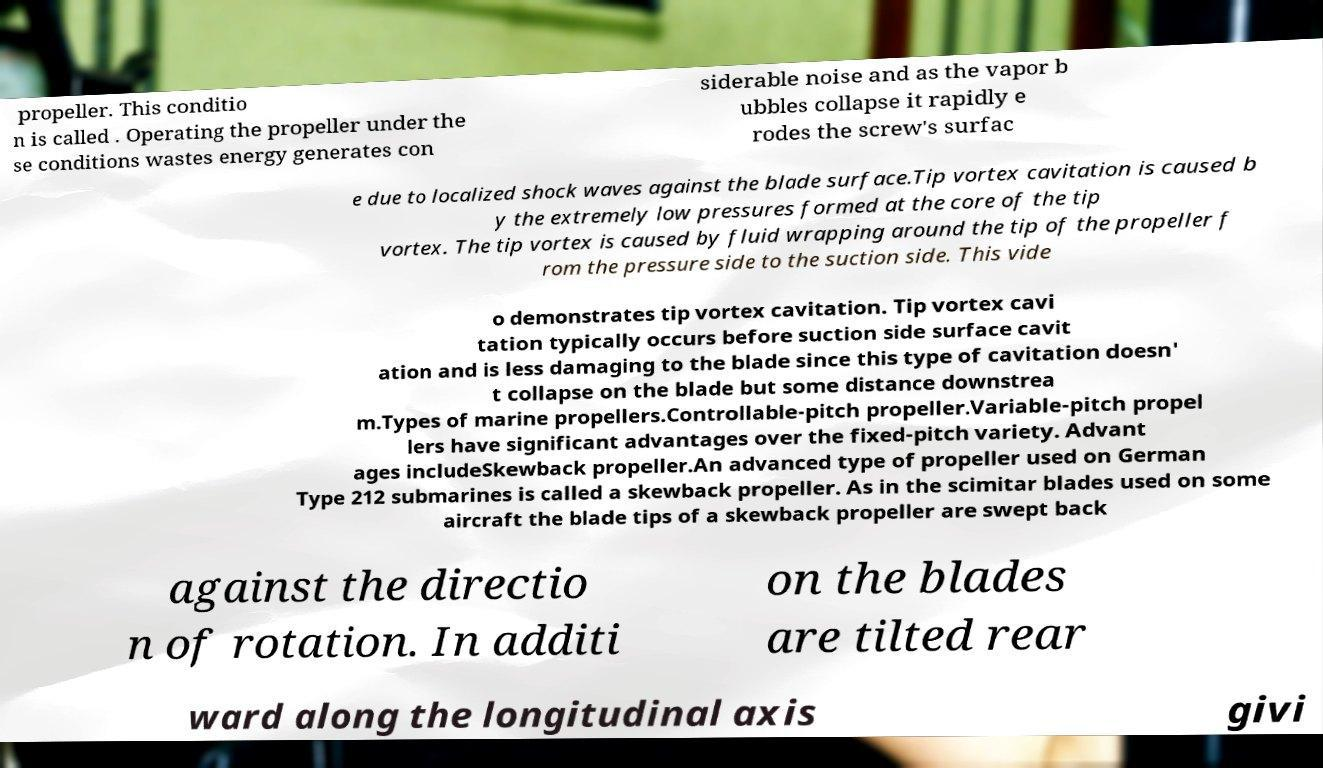Can you read and provide the text displayed in the image?This photo seems to have some interesting text. Can you extract and type it out for me? propeller. This conditio n is called . Operating the propeller under the se conditions wastes energy generates con siderable noise and as the vapor b ubbles collapse it rapidly e rodes the screw's surfac e due to localized shock waves against the blade surface.Tip vortex cavitation is caused b y the extremely low pressures formed at the core of the tip vortex. The tip vortex is caused by fluid wrapping around the tip of the propeller f rom the pressure side to the suction side. This vide o demonstrates tip vortex cavitation. Tip vortex cavi tation typically occurs before suction side surface cavit ation and is less damaging to the blade since this type of cavitation doesn' t collapse on the blade but some distance downstrea m.Types of marine propellers.Controllable-pitch propeller.Variable-pitch propel lers have significant advantages over the fixed-pitch variety. Advant ages includeSkewback propeller.An advanced type of propeller used on German Type 212 submarines is called a skewback propeller. As in the scimitar blades used on some aircraft the blade tips of a skewback propeller are swept back against the directio n of rotation. In additi on the blades are tilted rear ward along the longitudinal axis givi 